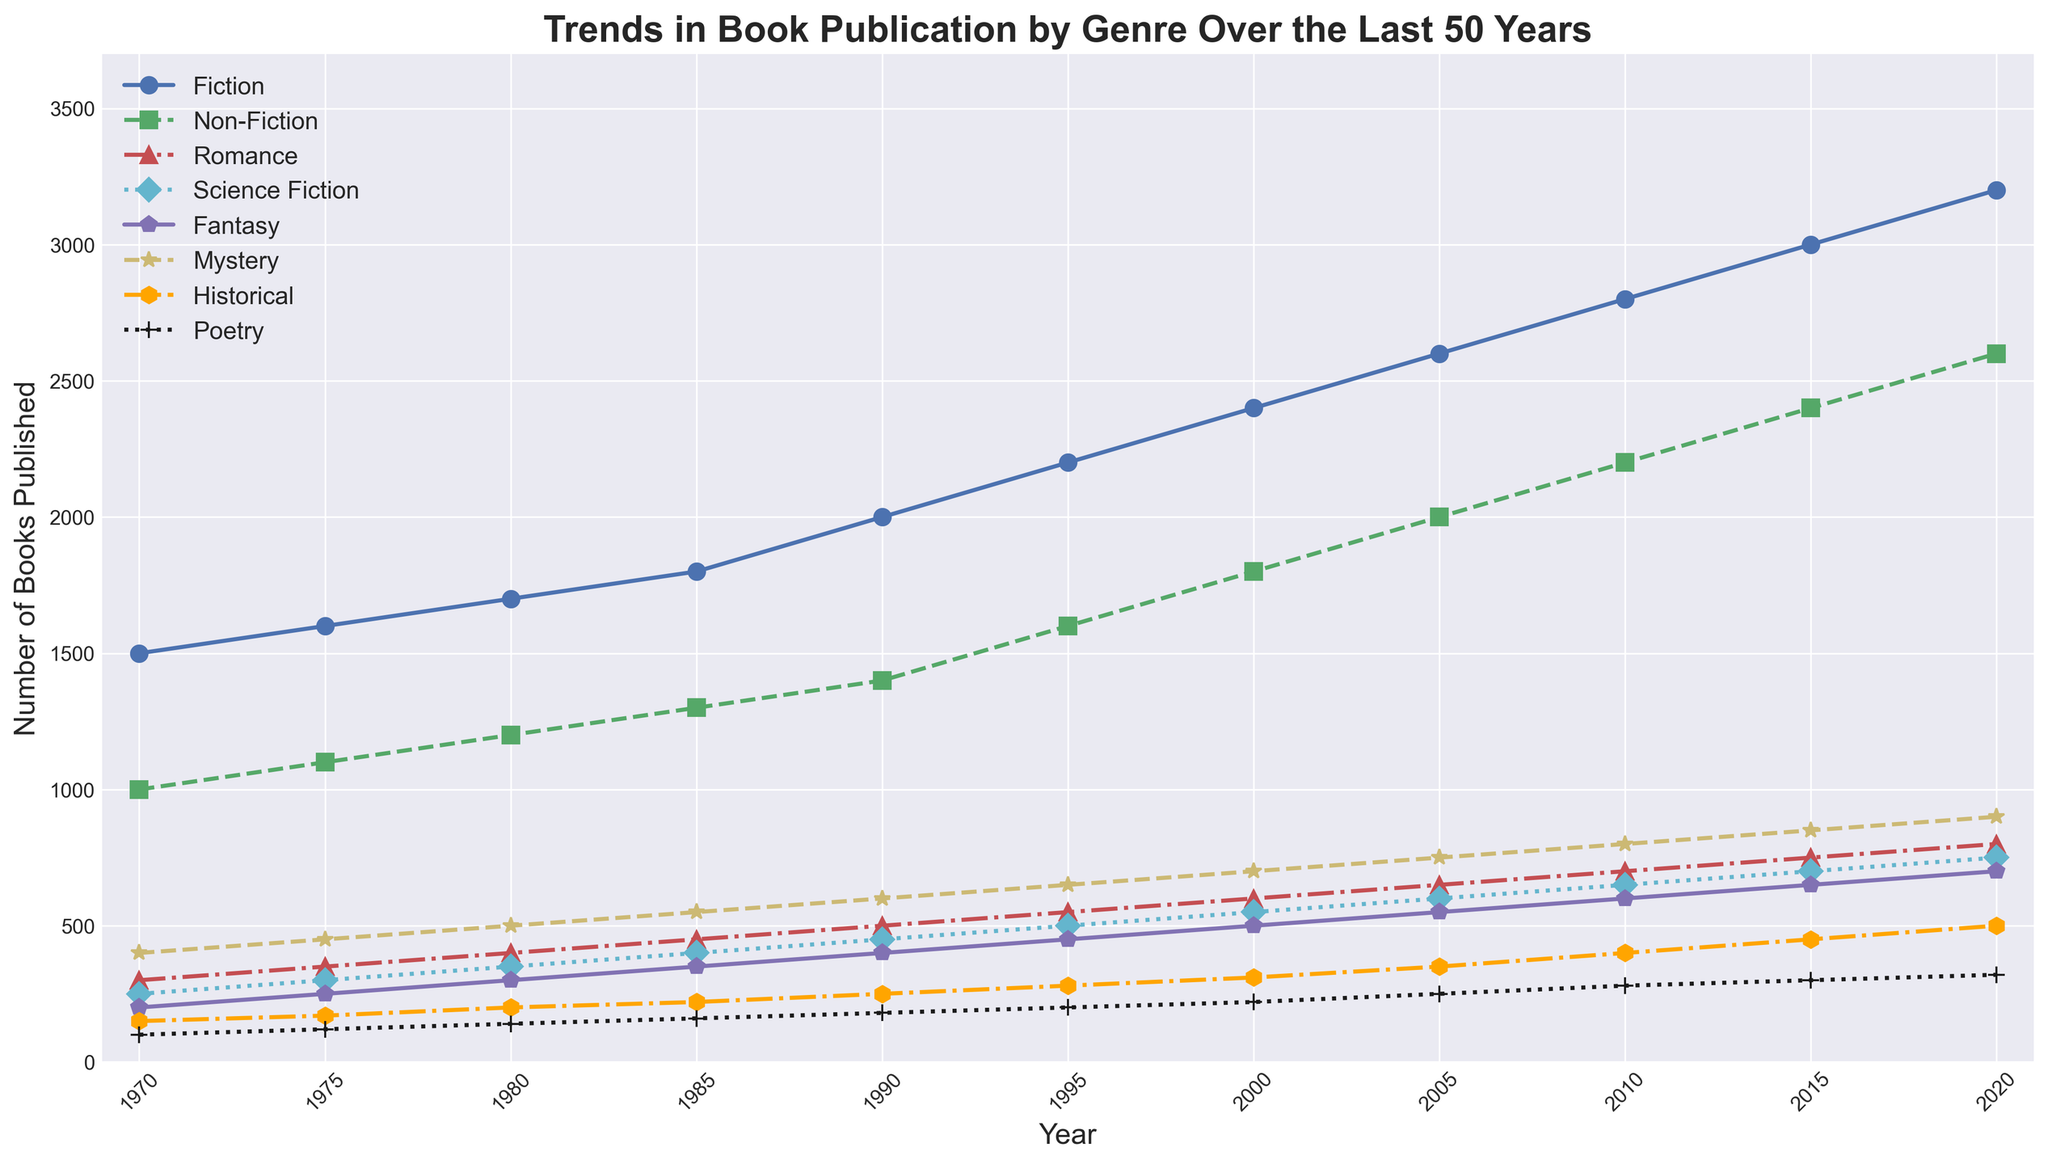When did the publication of Fiction books first exceed 2000 per year? Look at the 'Fiction' line and find the first year when its value is above 2000. In the year 1990, Fiction books reach 2000, and exceed it in the next year, 1995.
Answer: 1995 Which genre had the lowest number of publications in 1970? Observe the 1970 value for all genres and identify the one with the smallest value. In 1970, Poetry had the lowest number of publications at 100.
Answer: Poetry Between which two consecutive years did the Romance genre see the largest increase in publications? Identify the differences in the 'Romance' line's values for each pair of consecutive years. The largest increase is between 1990 and 1995, from 500 to 550.
Answer: 1990 and 1995 What is the average number of Mystery books published per year from 2000 to 2020? Add the Mystery values for each year from 2000 to 2020 and divide by the number of years. The values are [700, 750, 800, 850, 900], summing up to 4000; average is 4000 / 5 = 800.
Answer: 800 In which year did Non-Fiction publications first surpass Fiction publications? Compare the 'Fiction' and 'Non-Fiction' lines to find the first year where the 'Non-Fiction' line is higher. Non-Fiction does not surpass Fiction in any year.
Answer: Never How does the growth in Science Fiction publications compare between the 1970s and 1980s? Calculate the increase in Science Fiction publications for each decade. From 1970-1980, the growth is 350-250=100. From 1980-1990, it is 450-350=100. The growth is the same for both decades.
Answer: Equal Which genre experienced the highest percentage increase in publications between 1970 and 2020? Calculate the percentage increase for each genre from 1970 to 2020. The formula is (Number in 2020 - Number in 1970) / Number in 1970 * 100. Choose the highest result. For Poetry: (320-100)/100*100 = 220%, for Fiction: (3200-1500)/1500*100 = 113.33%, for Non-Fiction: (2600-1000)/1000*100 = 160%, and so on. Poetry has the highest percentage increase.
Answer: Poetry What is the difference between the highest and lowest number of Fiction books published within the given years? Identify the maximum and minimum values of Fiction books and subtract the lowest from the highest. Highest is 3200 (2020), lowest is 1500 (1970). Difference: 3200 - 1500 = 1700.
Answer: 1700 